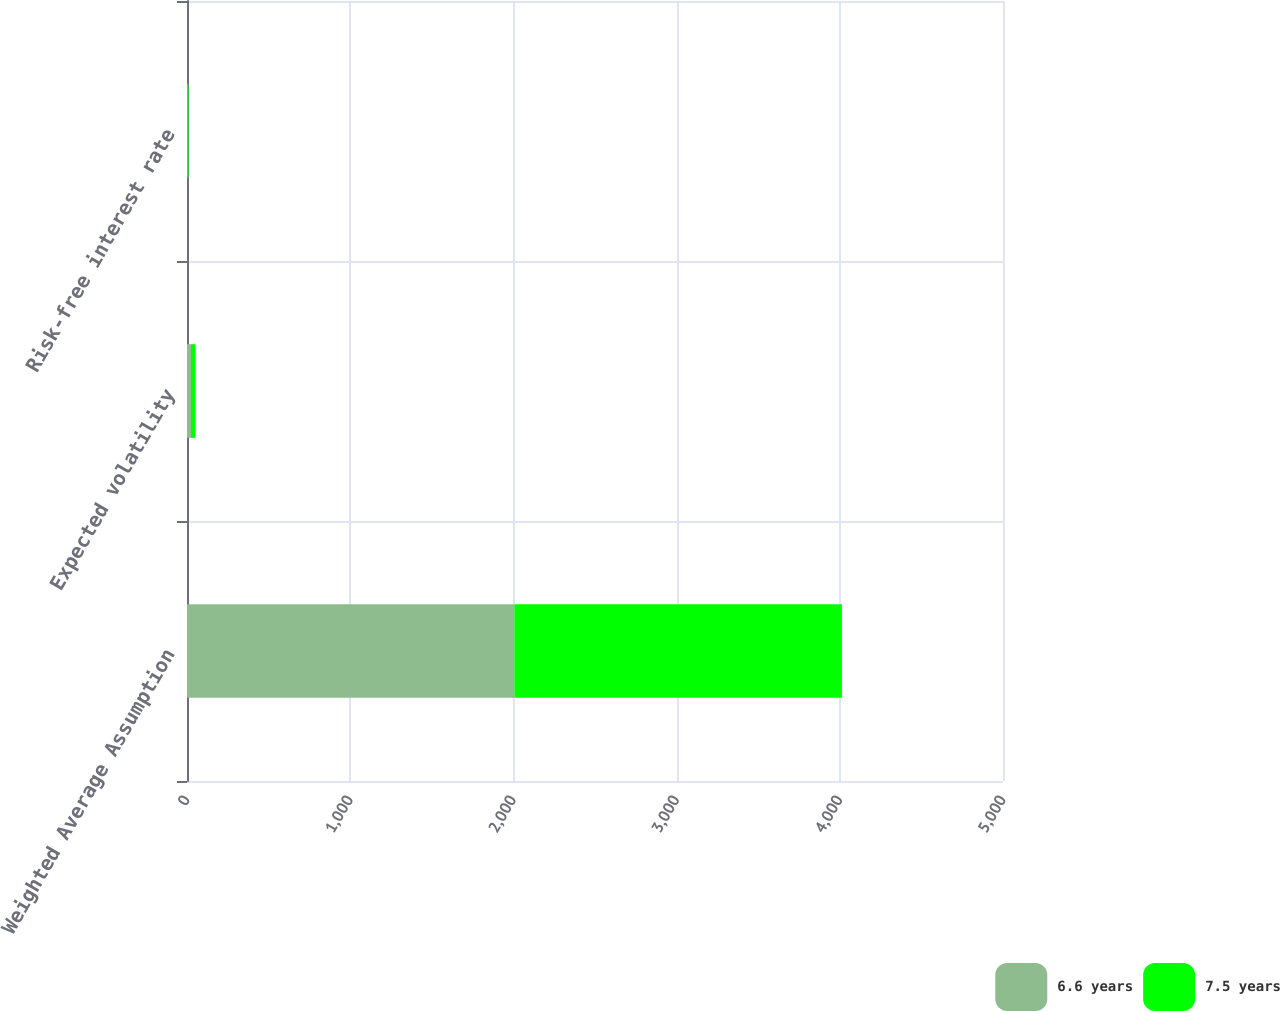Convert chart to OTSL. <chart><loc_0><loc_0><loc_500><loc_500><stacked_bar_chart><ecel><fcel>Weighted Average Assumption<fcel>Expected volatility<fcel>Risk-free interest rate<nl><fcel>6.6 years<fcel>2006<fcel>24.2<fcel>4.66<nl><fcel>7.5 years<fcel>2007<fcel>27.7<fcel>4.42<nl></chart> 